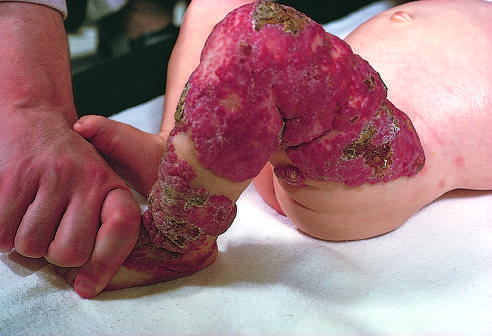when did the congenital capillary hemangioma after the lesion undergone spontaneous regression?
Answer the question using a single word or phrase. At 2 years of age after the lesion 